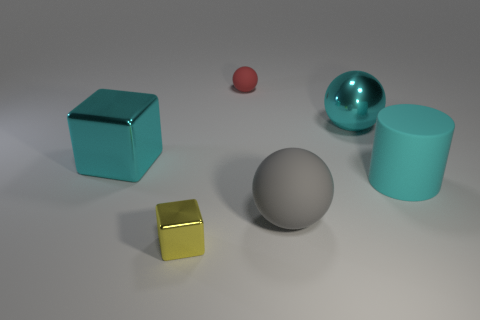Add 2 yellow metal blocks. How many objects exist? 8 Subtract all cylinders. How many objects are left? 5 Subtract 0 blue cylinders. How many objects are left? 6 Subtract all large blue things. Subtract all rubber objects. How many objects are left? 3 Add 6 tiny yellow shiny cubes. How many tiny yellow shiny cubes are left? 7 Add 2 small cyan matte balls. How many small cyan matte balls exist? 2 